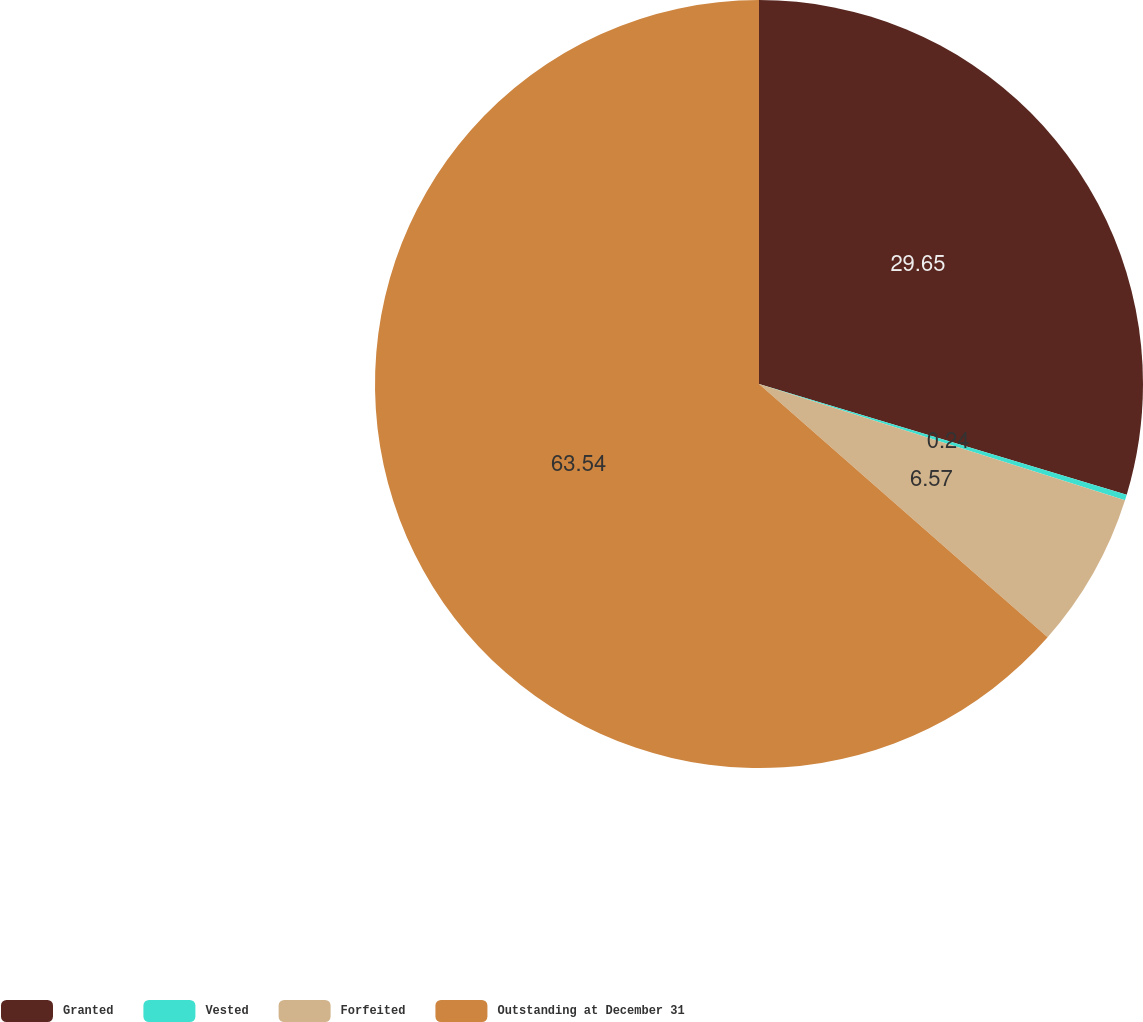Convert chart to OTSL. <chart><loc_0><loc_0><loc_500><loc_500><pie_chart><fcel>Granted<fcel>Vested<fcel>Forfeited<fcel>Outstanding at December 31<nl><fcel>29.65%<fcel>0.24%<fcel>6.57%<fcel>63.53%<nl></chart> 